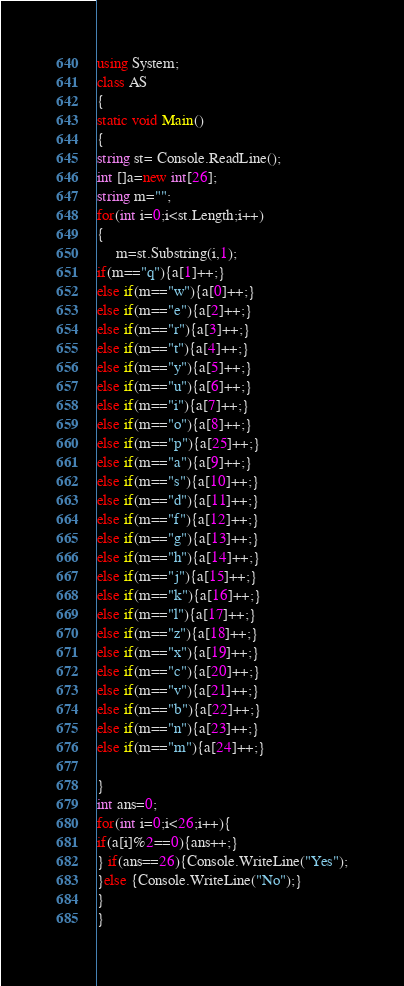<code> <loc_0><loc_0><loc_500><loc_500><_C#_>using System;
class AS
{
static void Main()
{
string st= Console.ReadLine();
int []a=new int[26];
string m="";
for(int i=0;i<st.Length;i++)
{
     m=st.Substring(i,1);
if(m=="q"){a[1]++;}
else if(m=="w"){a[0]++;}
else if(m=="e"){a[2]++;}
else if(m=="r"){a[3]++;}
else if(m=="t"){a[4]++;}
else if(m=="y"){a[5]++;}
else if(m=="u"){a[6]++;}
else if(m=="i"){a[7]++;}
else if(m=="o"){a[8]++;}
else if(m=="p"){a[25]++;}
else if(m=="a"){a[9]++;}
else if(m=="s"){a[10]++;}
else if(m=="d"){a[11]++;}
else if(m=="f"){a[12]++;}
else if(m=="g"){a[13]++;}
else if(m=="h"){a[14]++;}
else if(m=="j"){a[15]++;}
else if(m=="k"){a[16]++;}
else if(m=="l"){a[17]++;}
else if(m=="z"){a[18]++;}
else if(m=="x"){a[19]++;}
else if(m=="c"){a[20]++;}
else if(m=="v"){a[21]++;}
else if(m=="b"){a[22]++;}
else if(m=="n"){a[23]++;}
else if(m=="m"){a[24]++;}

}
int ans=0;
for(int i=0;i<26;i++){
if(a[i]%2==0){ans++;}
} if(ans==26){Console.WriteLine("Yes");
}else {Console.WriteLine("No");}
}
}</code> 